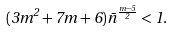<formula> <loc_0><loc_0><loc_500><loc_500>( 3 m ^ { 2 } + 7 m + 6 ) \bar { n } ^ { \frac { m - 5 } { 2 } } < 1 .</formula> 